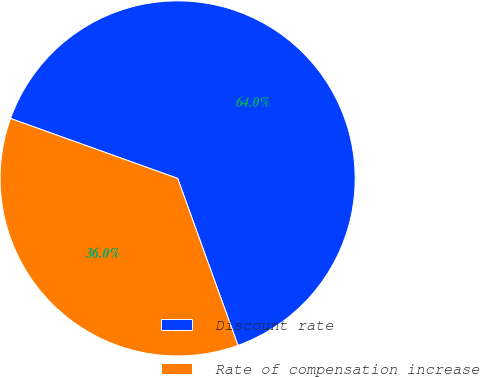<chart> <loc_0><loc_0><loc_500><loc_500><pie_chart><fcel>Discount rate<fcel>Rate of compensation increase<nl><fcel>64.0%<fcel>36.0%<nl></chart> 